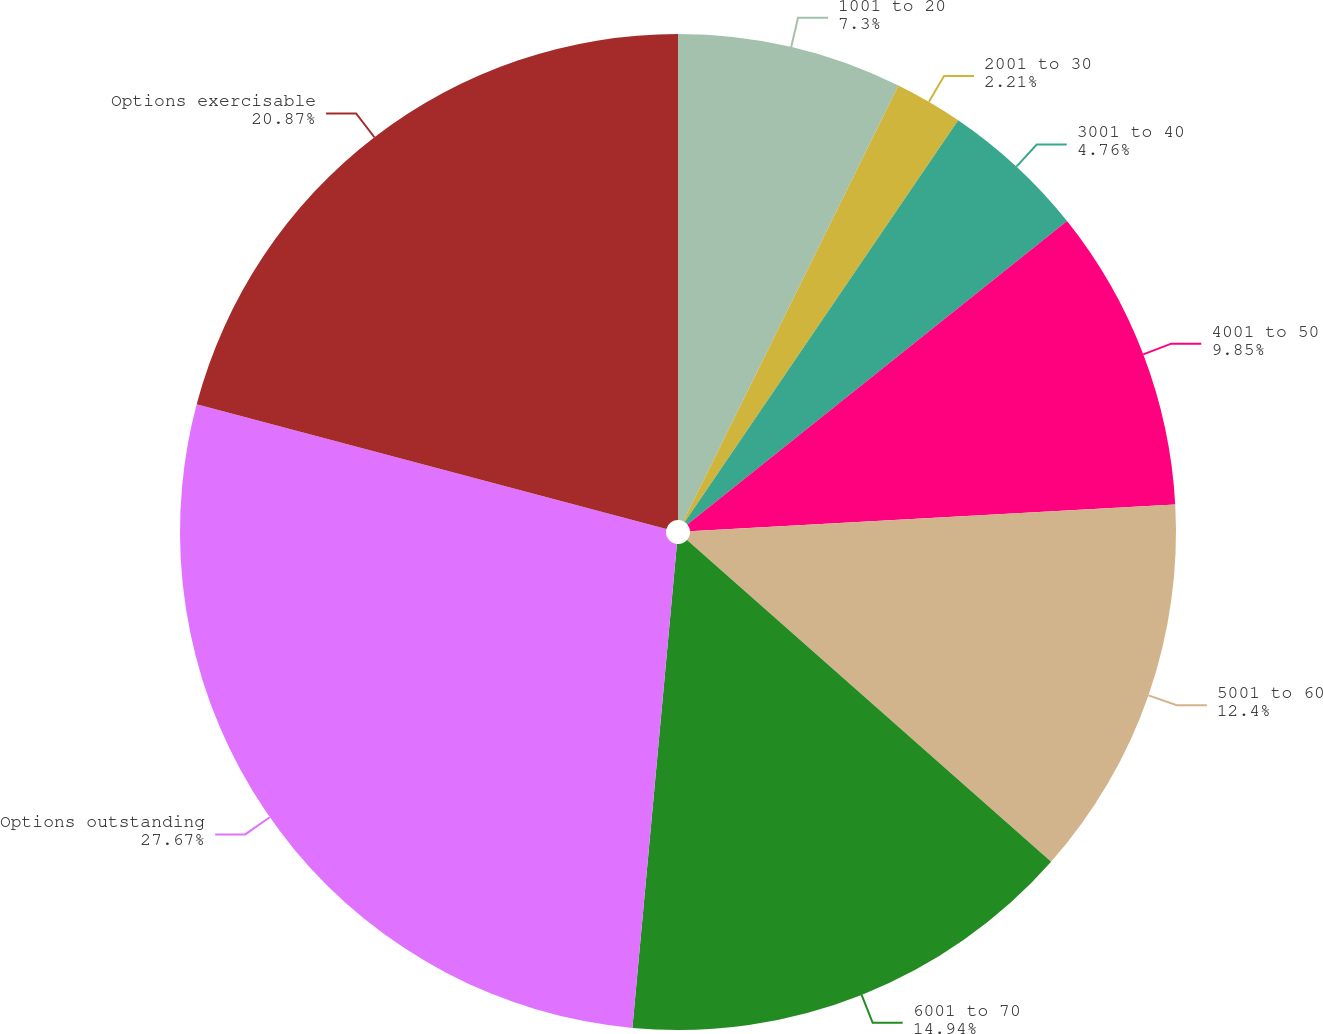<chart> <loc_0><loc_0><loc_500><loc_500><pie_chart><fcel>1001 to 20<fcel>2001 to 30<fcel>3001 to 40<fcel>4001 to 50<fcel>5001 to 60<fcel>6001 to 70<fcel>Options outstanding<fcel>Options exercisable<nl><fcel>7.3%<fcel>2.21%<fcel>4.76%<fcel>9.85%<fcel>12.4%<fcel>14.94%<fcel>27.67%<fcel>20.87%<nl></chart> 